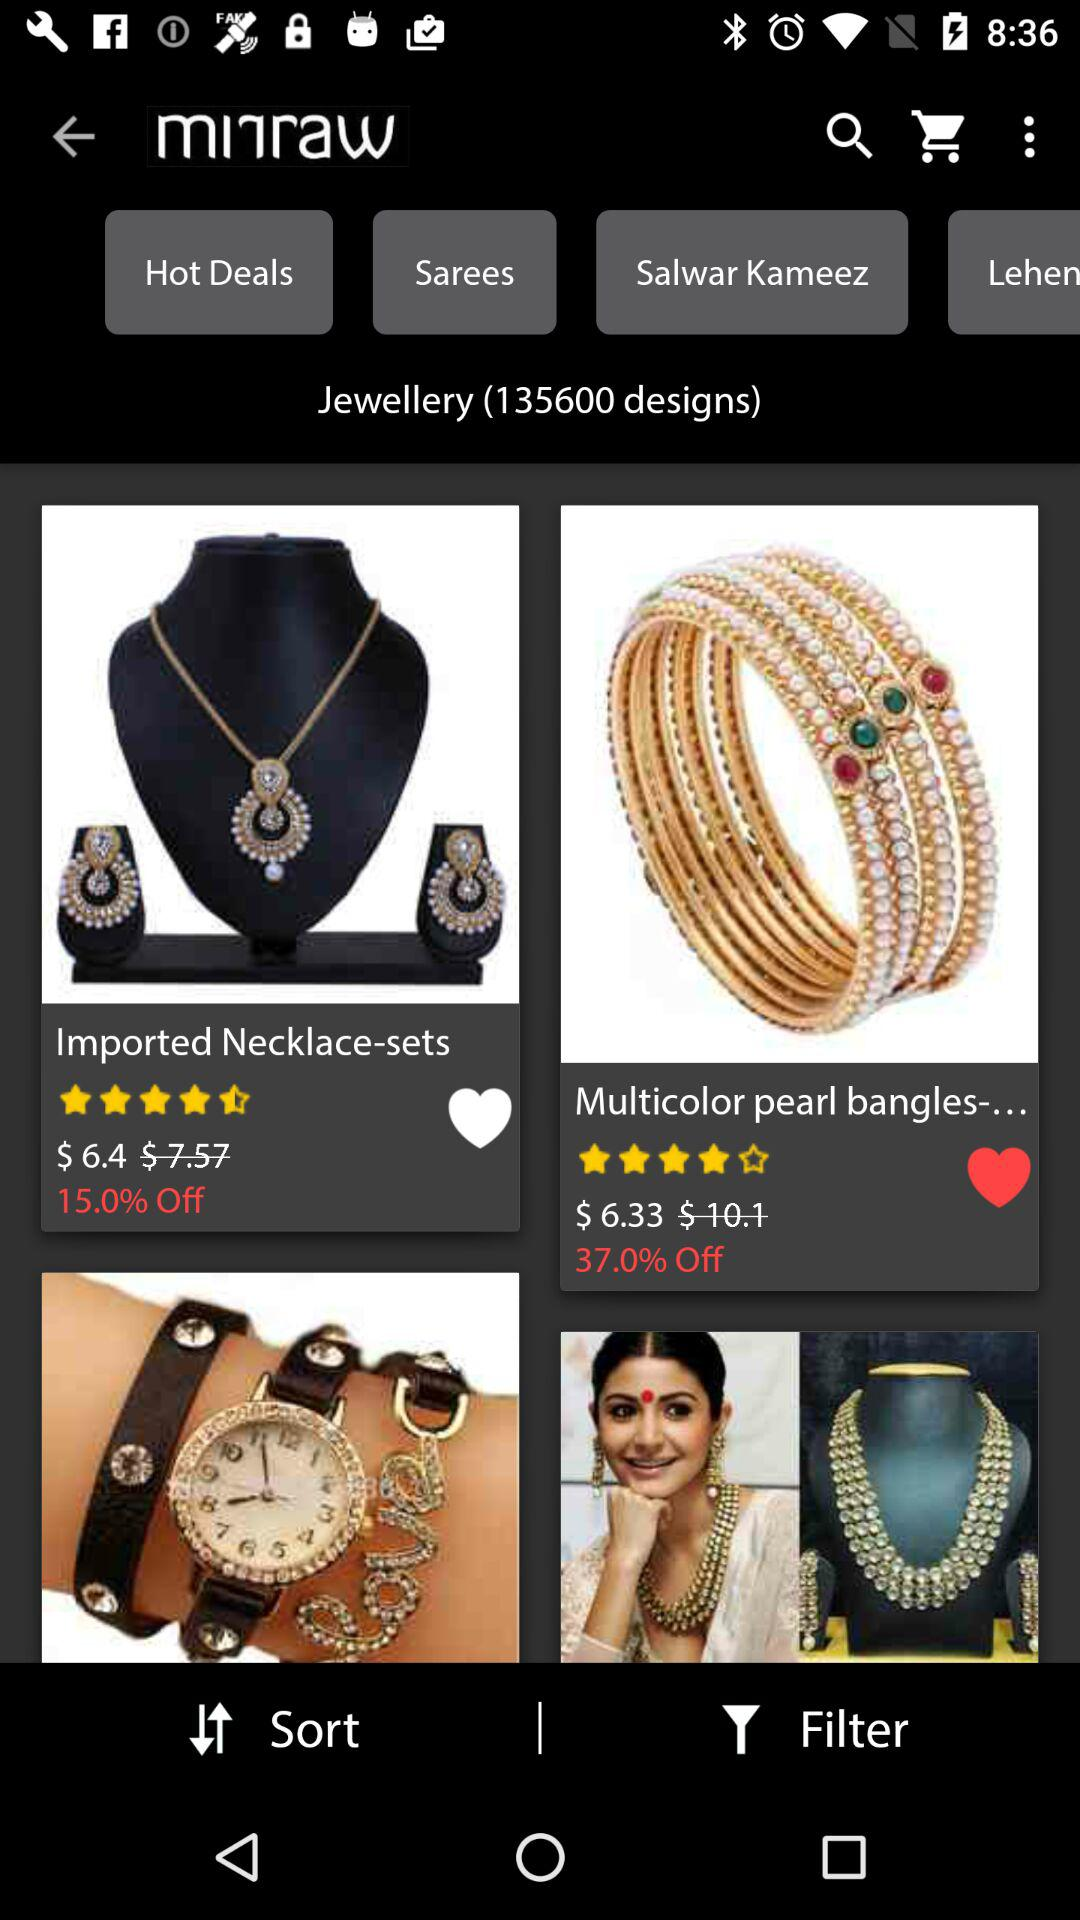How much is the cost of the necklace sets? The cost of the necklace sets is $6.4. 